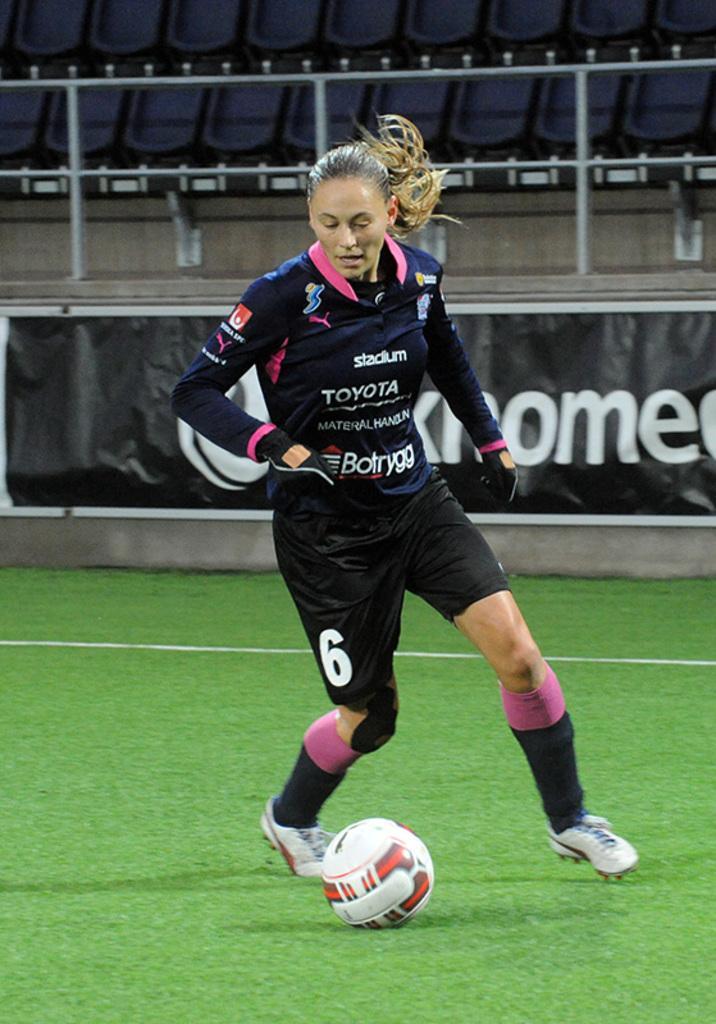Describe this image in one or two sentences. This picture might be taken inside a playground. In this image, in the middle, we can see a woman playing a football. At the bottom, we can see a football which is placed at a grass. In the background, we can see hoardings and a metal rods. 